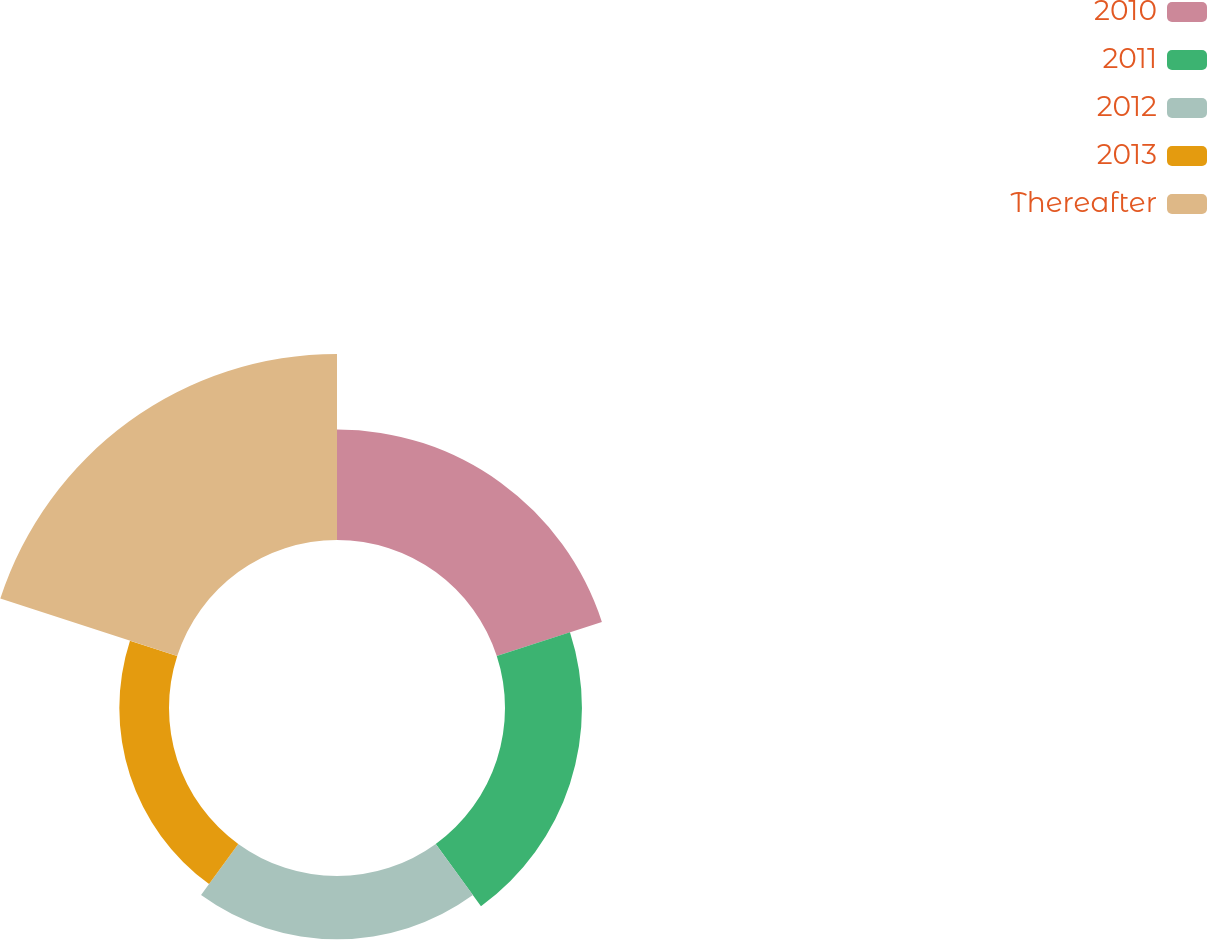Convert chart. <chart><loc_0><loc_0><loc_500><loc_500><pie_chart><fcel>2010<fcel>2011<fcel>2012<fcel>2013<fcel>Thereafter<nl><fcel>22.72%<fcel>15.82%<fcel>13.01%<fcel>10.21%<fcel>38.24%<nl></chart> 